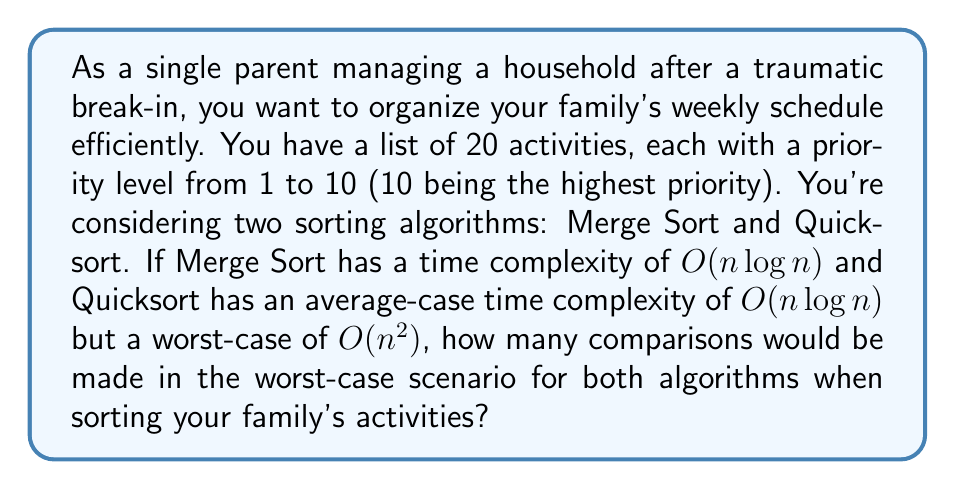What is the answer to this math problem? Let's approach this step-by-step:

1) We have $n = 20$ activities to sort.

2) For Merge Sort:
   - The time complexity is always $O(n \log n)$.
   - The number of comparisons in the worst case is approximately:
     $$C_{merge} = n \log_2 n$$
   - Substituting $n = 20$:
     $$C_{merge} = 20 \log_2 20 \approx 20 * 4.32 \approx 86.4$$
   - Rounding up, we get 87 comparisons.

3) For Quicksort:
   - The worst-case scenario occurs when the pivot is always the smallest or largest element, resulting in unbalanced partitions.
   - In this case, the number of comparisons is:
     $$C_{quick} = \frac{n(n-1)}{2}$$
   - Substituting $n = 20$:
     $$C_{quick} = \frac{20(20-1)}{2} = \frac{20 * 19}{2} = 190$$

4) Comparing the results:
   - Merge Sort: 87 comparisons
   - Quicksort: 190 comparisons

In the worst-case scenario, Quicksort would make significantly more comparisons than Merge Sort for organizing your family's activities.
Answer: Merge Sort: 87 comparisons
Quicksort: 190 comparisons 